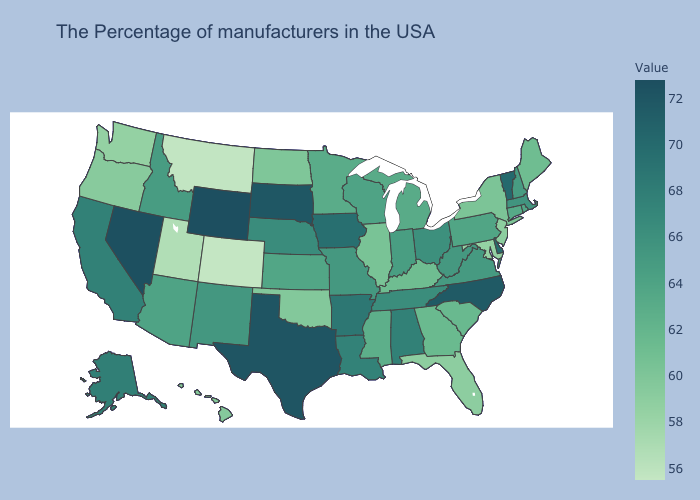Which states hav the highest value in the Northeast?
Keep it brief. Vermont. Which states have the lowest value in the USA?
Write a very short answer. Colorado. Does Texas have a lower value than Arkansas?
Give a very brief answer. No. Does Tennessee have a lower value than Florida?
Quick response, please. No. Which states have the lowest value in the USA?
Short answer required. Colorado. Does Minnesota have a higher value than Oregon?
Be succinct. Yes. 